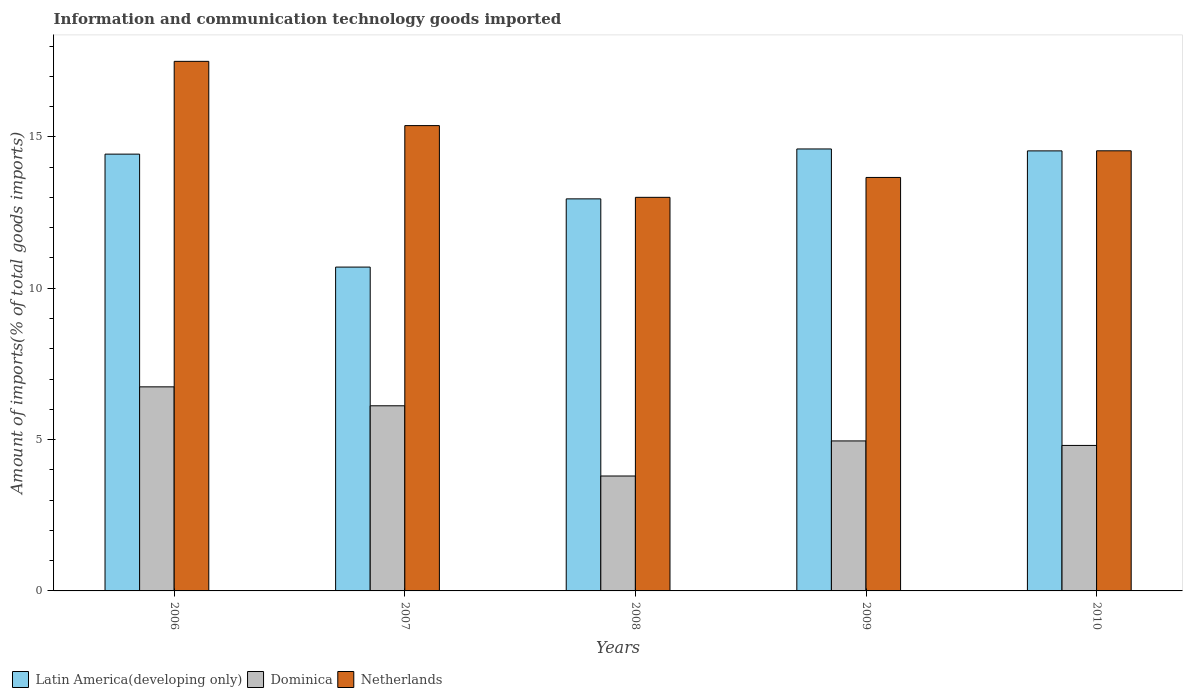How many different coloured bars are there?
Ensure brevity in your answer.  3. Are the number of bars per tick equal to the number of legend labels?
Your answer should be compact. Yes. How many bars are there on the 4th tick from the left?
Provide a succinct answer. 3. What is the label of the 5th group of bars from the left?
Provide a succinct answer. 2010. In how many cases, is the number of bars for a given year not equal to the number of legend labels?
Provide a short and direct response. 0. What is the amount of goods imported in Netherlands in 2008?
Your answer should be compact. 13. Across all years, what is the maximum amount of goods imported in Dominica?
Your answer should be compact. 6.74. Across all years, what is the minimum amount of goods imported in Netherlands?
Keep it short and to the point. 13. What is the total amount of goods imported in Latin America(developing only) in the graph?
Give a very brief answer. 67.21. What is the difference between the amount of goods imported in Dominica in 2008 and that in 2009?
Offer a terse response. -1.16. What is the difference between the amount of goods imported in Netherlands in 2008 and the amount of goods imported in Latin America(developing only) in 2009?
Your response must be concise. -1.6. What is the average amount of goods imported in Netherlands per year?
Give a very brief answer. 14.81. In the year 2006, what is the difference between the amount of goods imported in Latin America(developing only) and amount of goods imported in Dominica?
Offer a very short reply. 7.69. In how many years, is the amount of goods imported in Dominica greater than 14 %?
Provide a short and direct response. 0. What is the ratio of the amount of goods imported in Netherlands in 2009 to that in 2010?
Ensure brevity in your answer.  0.94. Is the difference between the amount of goods imported in Latin America(developing only) in 2006 and 2009 greater than the difference between the amount of goods imported in Dominica in 2006 and 2009?
Offer a very short reply. No. What is the difference between the highest and the second highest amount of goods imported in Latin America(developing only)?
Offer a terse response. 0.06. What is the difference between the highest and the lowest amount of goods imported in Dominica?
Offer a terse response. 2.95. In how many years, is the amount of goods imported in Dominica greater than the average amount of goods imported in Dominica taken over all years?
Keep it short and to the point. 2. Is the sum of the amount of goods imported in Dominica in 2006 and 2010 greater than the maximum amount of goods imported in Netherlands across all years?
Your response must be concise. No. What does the 2nd bar from the left in 2008 represents?
Your answer should be very brief. Dominica. Is it the case that in every year, the sum of the amount of goods imported in Netherlands and amount of goods imported in Dominica is greater than the amount of goods imported in Latin America(developing only)?
Give a very brief answer. Yes. What is the difference between two consecutive major ticks on the Y-axis?
Make the answer very short. 5. Does the graph contain grids?
Provide a short and direct response. No. Where does the legend appear in the graph?
Offer a very short reply. Bottom left. How are the legend labels stacked?
Offer a terse response. Horizontal. What is the title of the graph?
Ensure brevity in your answer.  Information and communication technology goods imported. What is the label or title of the Y-axis?
Provide a short and direct response. Amount of imports(% of total goods imports). What is the Amount of imports(% of total goods imports) in Latin America(developing only) in 2006?
Give a very brief answer. 14.43. What is the Amount of imports(% of total goods imports) of Dominica in 2006?
Offer a terse response. 6.74. What is the Amount of imports(% of total goods imports) of Netherlands in 2006?
Give a very brief answer. 17.49. What is the Amount of imports(% of total goods imports) of Latin America(developing only) in 2007?
Ensure brevity in your answer.  10.7. What is the Amount of imports(% of total goods imports) in Dominica in 2007?
Give a very brief answer. 6.12. What is the Amount of imports(% of total goods imports) of Netherlands in 2007?
Your answer should be compact. 15.37. What is the Amount of imports(% of total goods imports) in Latin America(developing only) in 2008?
Your response must be concise. 12.95. What is the Amount of imports(% of total goods imports) in Dominica in 2008?
Your answer should be very brief. 3.8. What is the Amount of imports(% of total goods imports) of Netherlands in 2008?
Provide a short and direct response. 13. What is the Amount of imports(% of total goods imports) of Latin America(developing only) in 2009?
Provide a short and direct response. 14.6. What is the Amount of imports(% of total goods imports) in Dominica in 2009?
Keep it short and to the point. 4.95. What is the Amount of imports(% of total goods imports) of Netherlands in 2009?
Offer a terse response. 13.66. What is the Amount of imports(% of total goods imports) of Latin America(developing only) in 2010?
Offer a terse response. 14.54. What is the Amount of imports(% of total goods imports) in Dominica in 2010?
Ensure brevity in your answer.  4.81. What is the Amount of imports(% of total goods imports) of Netherlands in 2010?
Your response must be concise. 14.54. Across all years, what is the maximum Amount of imports(% of total goods imports) of Latin America(developing only)?
Give a very brief answer. 14.6. Across all years, what is the maximum Amount of imports(% of total goods imports) of Dominica?
Your response must be concise. 6.74. Across all years, what is the maximum Amount of imports(% of total goods imports) in Netherlands?
Your answer should be very brief. 17.49. Across all years, what is the minimum Amount of imports(% of total goods imports) of Latin America(developing only)?
Give a very brief answer. 10.7. Across all years, what is the minimum Amount of imports(% of total goods imports) of Dominica?
Your answer should be very brief. 3.8. Across all years, what is the minimum Amount of imports(% of total goods imports) in Netherlands?
Ensure brevity in your answer.  13. What is the total Amount of imports(% of total goods imports) in Latin America(developing only) in the graph?
Keep it short and to the point. 67.21. What is the total Amount of imports(% of total goods imports) in Dominica in the graph?
Give a very brief answer. 26.41. What is the total Amount of imports(% of total goods imports) of Netherlands in the graph?
Make the answer very short. 74.06. What is the difference between the Amount of imports(% of total goods imports) of Latin America(developing only) in 2006 and that in 2007?
Offer a terse response. 3.73. What is the difference between the Amount of imports(% of total goods imports) of Dominica in 2006 and that in 2007?
Ensure brevity in your answer.  0.63. What is the difference between the Amount of imports(% of total goods imports) of Netherlands in 2006 and that in 2007?
Your answer should be very brief. 2.12. What is the difference between the Amount of imports(% of total goods imports) in Latin America(developing only) in 2006 and that in 2008?
Offer a very short reply. 1.48. What is the difference between the Amount of imports(% of total goods imports) in Dominica in 2006 and that in 2008?
Provide a short and direct response. 2.95. What is the difference between the Amount of imports(% of total goods imports) of Netherlands in 2006 and that in 2008?
Give a very brief answer. 4.49. What is the difference between the Amount of imports(% of total goods imports) in Latin America(developing only) in 2006 and that in 2009?
Offer a terse response. -0.17. What is the difference between the Amount of imports(% of total goods imports) in Dominica in 2006 and that in 2009?
Keep it short and to the point. 1.79. What is the difference between the Amount of imports(% of total goods imports) of Netherlands in 2006 and that in 2009?
Keep it short and to the point. 3.84. What is the difference between the Amount of imports(% of total goods imports) of Latin America(developing only) in 2006 and that in 2010?
Give a very brief answer. -0.11. What is the difference between the Amount of imports(% of total goods imports) of Dominica in 2006 and that in 2010?
Provide a succinct answer. 1.94. What is the difference between the Amount of imports(% of total goods imports) of Netherlands in 2006 and that in 2010?
Your answer should be compact. 2.96. What is the difference between the Amount of imports(% of total goods imports) in Latin America(developing only) in 2007 and that in 2008?
Your answer should be very brief. -2.25. What is the difference between the Amount of imports(% of total goods imports) in Dominica in 2007 and that in 2008?
Provide a short and direct response. 2.32. What is the difference between the Amount of imports(% of total goods imports) of Netherlands in 2007 and that in 2008?
Offer a very short reply. 2.37. What is the difference between the Amount of imports(% of total goods imports) in Latin America(developing only) in 2007 and that in 2009?
Your response must be concise. -3.9. What is the difference between the Amount of imports(% of total goods imports) of Dominica in 2007 and that in 2009?
Give a very brief answer. 1.16. What is the difference between the Amount of imports(% of total goods imports) in Netherlands in 2007 and that in 2009?
Provide a short and direct response. 1.71. What is the difference between the Amount of imports(% of total goods imports) in Latin America(developing only) in 2007 and that in 2010?
Keep it short and to the point. -3.84. What is the difference between the Amount of imports(% of total goods imports) in Dominica in 2007 and that in 2010?
Give a very brief answer. 1.31. What is the difference between the Amount of imports(% of total goods imports) of Netherlands in 2007 and that in 2010?
Offer a terse response. 0.83. What is the difference between the Amount of imports(% of total goods imports) in Latin America(developing only) in 2008 and that in 2009?
Your answer should be compact. -1.65. What is the difference between the Amount of imports(% of total goods imports) in Dominica in 2008 and that in 2009?
Offer a terse response. -1.16. What is the difference between the Amount of imports(% of total goods imports) in Netherlands in 2008 and that in 2009?
Offer a terse response. -0.66. What is the difference between the Amount of imports(% of total goods imports) of Latin America(developing only) in 2008 and that in 2010?
Your response must be concise. -1.58. What is the difference between the Amount of imports(% of total goods imports) in Dominica in 2008 and that in 2010?
Provide a succinct answer. -1.01. What is the difference between the Amount of imports(% of total goods imports) in Netherlands in 2008 and that in 2010?
Your response must be concise. -1.54. What is the difference between the Amount of imports(% of total goods imports) of Latin America(developing only) in 2009 and that in 2010?
Your answer should be compact. 0.06. What is the difference between the Amount of imports(% of total goods imports) in Dominica in 2009 and that in 2010?
Keep it short and to the point. 0.15. What is the difference between the Amount of imports(% of total goods imports) of Netherlands in 2009 and that in 2010?
Your response must be concise. -0.88. What is the difference between the Amount of imports(% of total goods imports) in Latin America(developing only) in 2006 and the Amount of imports(% of total goods imports) in Dominica in 2007?
Provide a succinct answer. 8.31. What is the difference between the Amount of imports(% of total goods imports) in Latin America(developing only) in 2006 and the Amount of imports(% of total goods imports) in Netherlands in 2007?
Your response must be concise. -0.94. What is the difference between the Amount of imports(% of total goods imports) in Dominica in 2006 and the Amount of imports(% of total goods imports) in Netherlands in 2007?
Give a very brief answer. -8.63. What is the difference between the Amount of imports(% of total goods imports) in Latin America(developing only) in 2006 and the Amount of imports(% of total goods imports) in Dominica in 2008?
Keep it short and to the point. 10.63. What is the difference between the Amount of imports(% of total goods imports) of Latin America(developing only) in 2006 and the Amount of imports(% of total goods imports) of Netherlands in 2008?
Offer a very short reply. 1.43. What is the difference between the Amount of imports(% of total goods imports) of Dominica in 2006 and the Amount of imports(% of total goods imports) of Netherlands in 2008?
Offer a very short reply. -6.26. What is the difference between the Amount of imports(% of total goods imports) of Latin America(developing only) in 2006 and the Amount of imports(% of total goods imports) of Dominica in 2009?
Your answer should be very brief. 9.47. What is the difference between the Amount of imports(% of total goods imports) of Latin America(developing only) in 2006 and the Amount of imports(% of total goods imports) of Netherlands in 2009?
Ensure brevity in your answer.  0.77. What is the difference between the Amount of imports(% of total goods imports) in Dominica in 2006 and the Amount of imports(% of total goods imports) in Netherlands in 2009?
Make the answer very short. -6.92. What is the difference between the Amount of imports(% of total goods imports) in Latin America(developing only) in 2006 and the Amount of imports(% of total goods imports) in Dominica in 2010?
Provide a short and direct response. 9.62. What is the difference between the Amount of imports(% of total goods imports) in Latin America(developing only) in 2006 and the Amount of imports(% of total goods imports) in Netherlands in 2010?
Offer a terse response. -0.11. What is the difference between the Amount of imports(% of total goods imports) in Dominica in 2006 and the Amount of imports(% of total goods imports) in Netherlands in 2010?
Your answer should be compact. -7.8. What is the difference between the Amount of imports(% of total goods imports) in Latin America(developing only) in 2007 and the Amount of imports(% of total goods imports) in Dominica in 2008?
Your answer should be very brief. 6.9. What is the difference between the Amount of imports(% of total goods imports) in Latin America(developing only) in 2007 and the Amount of imports(% of total goods imports) in Netherlands in 2008?
Your answer should be compact. -2.3. What is the difference between the Amount of imports(% of total goods imports) of Dominica in 2007 and the Amount of imports(% of total goods imports) of Netherlands in 2008?
Provide a succinct answer. -6.89. What is the difference between the Amount of imports(% of total goods imports) of Latin America(developing only) in 2007 and the Amount of imports(% of total goods imports) of Dominica in 2009?
Your response must be concise. 5.74. What is the difference between the Amount of imports(% of total goods imports) of Latin America(developing only) in 2007 and the Amount of imports(% of total goods imports) of Netherlands in 2009?
Provide a short and direct response. -2.96. What is the difference between the Amount of imports(% of total goods imports) of Dominica in 2007 and the Amount of imports(% of total goods imports) of Netherlands in 2009?
Your answer should be compact. -7.54. What is the difference between the Amount of imports(% of total goods imports) of Latin America(developing only) in 2007 and the Amount of imports(% of total goods imports) of Dominica in 2010?
Offer a terse response. 5.89. What is the difference between the Amount of imports(% of total goods imports) of Latin America(developing only) in 2007 and the Amount of imports(% of total goods imports) of Netherlands in 2010?
Make the answer very short. -3.84. What is the difference between the Amount of imports(% of total goods imports) in Dominica in 2007 and the Amount of imports(% of total goods imports) in Netherlands in 2010?
Your response must be concise. -8.42. What is the difference between the Amount of imports(% of total goods imports) of Latin America(developing only) in 2008 and the Amount of imports(% of total goods imports) of Dominica in 2009?
Give a very brief answer. 8. What is the difference between the Amount of imports(% of total goods imports) in Latin America(developing only) in 2008 and the Amount of imports(% of total goods imports) in Netherlands in 2009?
Provide a succinct answer. -0.71. What is the difference between the Amount of imports(% of total goods imports) in Dominica in 2008 and the Amount of imports(% of total goods imports) in Netherlands in 2009?
Offer a terse response. -9.86. What is the difference between the Amount of imports(% of total goods imports) of Latin America(developing only) in 2008 and the Amount of imports(% of total goods imports) of Dominica in 2010?
Offer a very short reply. 8.14. What is the difference between the Amount of imports(% of total goods imports) in Latin America(developing only) in 2008 and the Amount of imports(% of total goods imports) in Netherlands in 2010?
Make the answer very short. -1.59. What is the difference between the Amount of imports(% of total goods imports) of Dominica in 2008 and the Amount of imports(% of total goods imports) of Netherlands in 2010?
Provide a short and direct response. -10.74. What is the difference between the Amount of imports(% of total goods imports) in Latin America(developing only) in 2009 and the Amount of imports(% of total goods imports) in Dominica in 2010?
Your answer should be compact. 9.79. What is the difference between the Amount of imports(% of total goods imports) in Latin America(developing only) in 2009 and the Amount of imports(% of total goods imports) in Netherlands in 2010?
Provide a succinct answer. 0.06. What is the difference between the Amount of imports(% of total goods imports) of Dominica in 2009 and the Amount of imports(% of total goods imports) of Netherlands in 2010?
Keep it short and to the point. -9.58. What is the average Amount of imports(% of total goods imports) of Latin America(developing only) per year?
Offer a very short reply. 13.44. What is the average Amount of imports(% of total goods imports) in Dominica per year?
Ensure brevity in your answer.  5.28. What is the average Amount of imports(% of total goods imports) in Netherlands per year?
Your answer should be very brief. 14.81. In the year 2006, what is the difference between the Amount of imports(% of total goods imports) of Latin America(developing only) and Amount of imports(% of total goods imports) of Dominica?
Your answer should be very brief. 7.69. In the year 2006, what is the difference between the Amount of imports(% of total goods imports) in Latin America(developing only) and Amount of imports(% of total goods imports) in Netherlands?
Your answer should be compact. -3.07. In the year 2006, what is the difference between the Amount of imports(% of total goods imports) in Dominica and Amount of imports(% of total goods imports) in Netherlands?
Your answer should be compact. -10.75. In the year 2007, what is the difference between the Amount of imports(% of total goods imports) of Latin America(developing only) and Amount of imports(% of total goods imports) of Dominica?
Provide a short and direct response. 4.58. In the year 2007, what is the difference between the Amount of imports(% of total goods imports) in Latin America(developing only) and Amount of imports(% of total goods imports) in Netherlands?
Make the answer very short. -4.67. In the year 2007, what is the difference between the Amount of imports(% of total goods imports) in Dominica and Amount of imports(% of total goods imports) in Netherlands?
Your response must be concise. -9.26. In the year 2008, what is the difference between the Amount of imports(% of total goods imports) of Latin America(developing only) and Amount of imports(% of total goods imports) of Dominica?
Give a very brief answer. 9.15. In the year 2008, what is the difference between the Amount of imports(% of total goods imports) of Latin America(developing only) and Amount of imports(% of total goods imports) of Netherlands?
Your answer should be compact. -0.05. In the year 2008, what is the difference between the Amount of imports(% of total goods imports) in Dominica and Amount of imports(% of total goods imports) in Netherlands?
Provide a short and direct response. -9.21. In the year 2009, what is the difference between the Amount of imports(% of total goods imports) of Latin America(developing only) and Amount of imports(% of total goods imports) of Dominica?
Provide a succinct answer. 9.64. In the year 2009, what is the difference between the Amount of imports(% of total goods imports) in Latin America(developing only) and Amount of imports(% of total goods imports) in Netherlands?
Offer a very short reply. 0.94. In the year 2009, what is the difference between the Amount of imports(% of total goods imports) of Dominica and Amount of imports(% of total goods imports) of Netherlands?
Keep it short and to the point. -8.7. In the year 2010, what is the difference between the Amount of imports(% of total goods imports) of Latin America(developing only) and Amount of imports(% of total goods imports) of Dominica?
Offer a very short reply. 9.73. In the year 2010, what is the difference between the Amount of imports(% of total goods imports) in Latin America(developing only) and Amount of imports(% of total goods imports) in Netherlands?
Give a very brief answer. -0. In the year 2010, what is the difference between the Amount of imports(% of total goods imports) of Dominica and Amount of imports(% of total goods imports) of Netherlands?
Provide a short and direct response. -9.73. What is the ratio of the Amount of imports(% of total goods imports) in Latin America(developing only) in 2006 to that in 2007?
Your answer should be compact. 1.35. What is the ratio of the Amount of imports(% of total goods imports) of Dominica in 2006 to that in 2007?
Your answer should be very brief. 1.1. What is the ratio of the Amount of imports(% of total goods imports) of Netherlands in 2006 to that in 2007?
Your answer should be very brief. 1.14. What is the ratio of the Amount of imports(% of total goods imports) in Latin America(developing only) in 2006 to that in 2008?
Ensure brevity in your answer.  1.11. What is the ratio of the Amount of imports(% of total goods imports) in Dominica in 2006 to that in 2008?
Ensure brevity in your answer.  1.78. What is the ratio of the Amount of imports(% of total goods imports) in Netherlands in 2006 to that in 2008?
Provide a short and direct response. 1.35. What is the ratio of the Amount of imports(% of total goods imports) of Latin America(developing only) in 2006 to that in 2009?
Give a very brief answer. 0.99. What is the ratio of the Amount of imports(% of total goods imports) of Dominica in 2006 to that in 2009?
Give a very brief answer. 1.36. What is the ratio of the Amount of imports(% of total goods imports) of Netherlands in 2006 to that in 2009?
Provide a succinct answer. 1.28. What is the ratio of the Amount of imports(% of total goods imports) in Latin America(developing only) in 2006 to that in 2010?
Your answer should be very brief. 0.99. What is the ratio of the Amount of imports(% of total goods imports) in Dominica in 2006 to that in 2010?
Your response must be concise. 1.4. What is the ratio of the Amount of imports(% of total goods imports) in Netherlands in 2006 to that in 2010?
Make the answer very short. 1.2. What is the ratio of the Amount of imports(% of total goods imports) of Latin America(developing only) in 2007 to that in 2008?
Keep it short and to the point. 0.83. What is the ratio of the Amount of imports(% of total goods imports) of Dominica in 2007 to that in 2008?
Provide a short and direct response. 1.61. What is the ratio of the Amount of imports(% of total goods imports) of Netherlands in 2007 to that in 2008?
Your answer should be very brief. 1.18. What is the ratio of the Amount of imports(% of total goods imports) of Latin America(developing only) in 2007 to that in 2009?
Make the answer very short. 0.73. What is the ratio of the Amount of imports(% of total goods imports) in Dominica in 2007 to that in 2009?
Ensure brevity in your answer.  1.23. What is the ratio of the Amount of imports(% of total goods imports) of Netherlands in 2007 to that in 2009?
Give a very brief answer. 1.13. What is the ratio of the Amount of imports(% of total goods imports) in Latin America(developing only) in 2007 to that in 2010?
Offer a very short reply. 0.74. What is the ratio of the Amount of imports(% of total goods imports) of Dominica in 2007 to that in 2010?
Offer a very short reply. 1.27. What is the ratio of the Amount of imports(% of total goods imports) of Netherlands in 2007 to that in 2010?
Give a very brief answer. 1.06. What is the ratio of the Amount of imports(% of total goods imports) in Latin America(developing only) in 2008 to that in 2009?
Your answer should be very brief. 0.89. What is the ratio of the Amount of imports(% of total goods imports) of Dominica in 2008 to that in 2009?
Give a very brief answer. 0.77. What is the ratio of the Amount of imports(% of total goods imports) of Netherlands in 2008 to that in 2009?
Provide a succinct answer. 0.95. What is the ratio of the Amount of imports(% of total goods imports) of Latin America(developing only) in 2008 to that in 2010?
Keep it short and to the point. 0.89. What is the ratio of the Amount of imports(% of total goods imports) in Dominica in 2008 to that in 2010?
Provide a succinct answer. 0.79. What is the ratio of the Amount of imports(% of total goods imports) in Netherlands in 2008 to that in 2010?
Make the answer very short. 0.89. What is the ratio of the Amount of imports(% of total goods imports) of Dominica in 2009 to that in 2010?
Your answer should be compact. 1.03. What is the ratio of the Amount of imports(% of total goods imports) of Netherlands in 2009 to that in 2010?
Keep it short and to the point. 0.94. What is the difference between the highest and the second highest Amount of imports(% of total goods imports) of Latin America(developing only)?
Give a very brief answer. 0.06. What is the difference between the highest and the second highest Amount of imports(% of total goods imports) of Dominica?
Your response must be concise. 0.63. What is the difference between the highest and the second highest Amount of imports(% of total goods imports) of Netherlands?
Your response must be concise. 2.12. What is the difference between the highest and the lowest Amount of imports(% of total goods imports) in Latin America(developing only)?
Offer a very short reply. 3.9. What is the difference between the highest and the lowest Amount of imports(% of total goods imports) in Dominica?
Ensure brevity in your answer.  2.95. What is the difference between the highest and the lowest Amount of imports(% of total goods imports) in Netherlands?
Give a very brief answer. 4.49. 